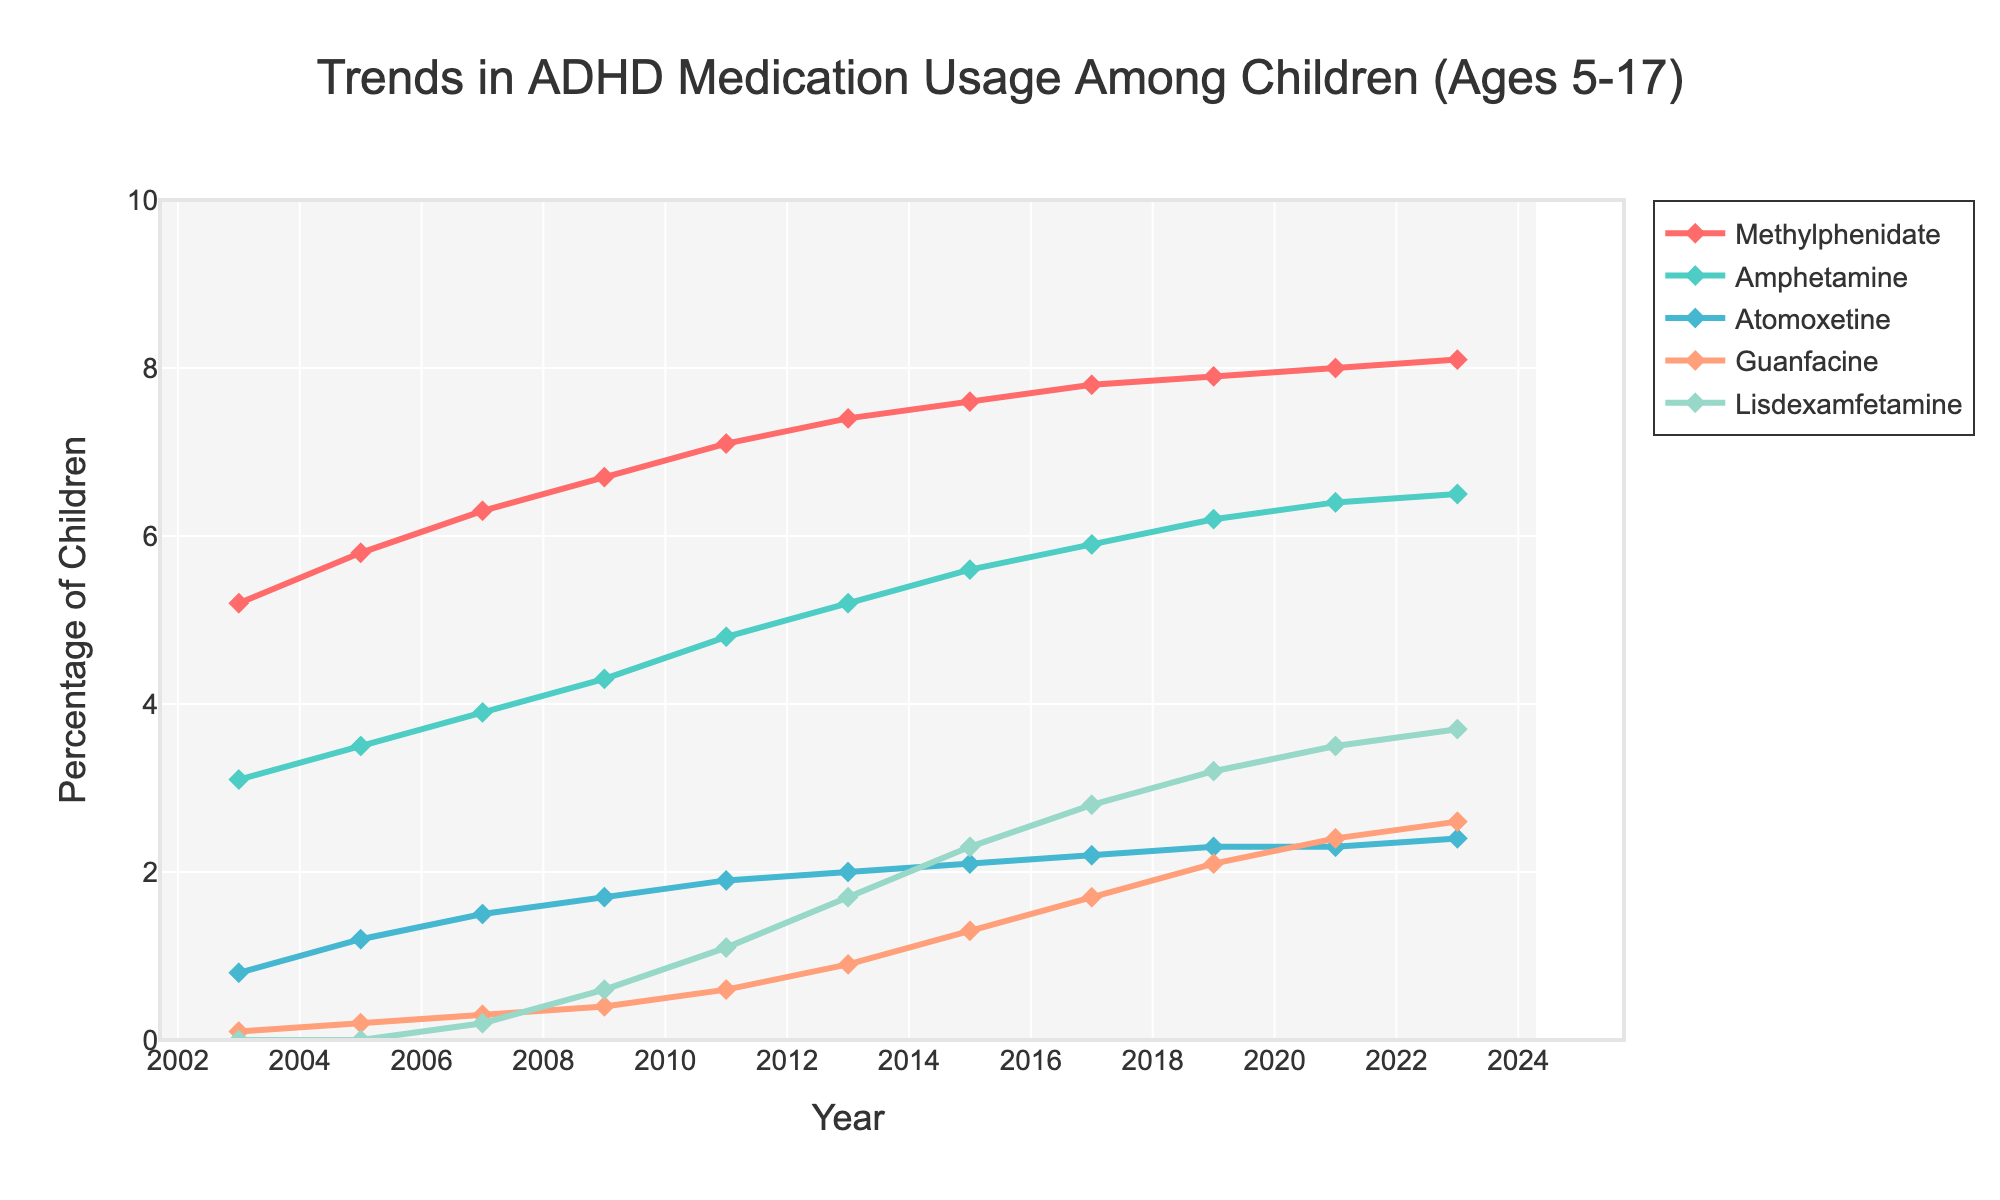What's the trend in Methylphenidate usage over the 20-year period? Methylphenidate usage increases from 5.2% in 2003 to 8.1% in 2023. Check each data point for Methylphenidate in the figure to notice the upward trend over time.
Answer: Increasing Which medication shows the most significant increase in usage over the 20 years? Calculate the increase in percentage for each medication: Methylphenidate (8.1-5.2=2.9), Amphetamine (6.5-3.1=3.4), Atomoxetine (2.4-0.8=1.6), Guanfacine (2.6-0.1=2.5), Lisdexamfetamine (3.7-0=3.7). The largest increase is for Lisdexamfetamine.
Answer: Lisdexamfetamine How does the 2023 usage of Guanfacine compare to Atomoxetine? In 2023, Guanfacine usage is 2.6% and Atomoxetine is 2.4%. Guanfacine usage is slightly higher.
Answer: Guanfacine is higher What is the difference in usage between Amphetamine and Atomoxetine in 2021? In 2021, Amphetamine is 6.4% and Atomoxetine is 2.3%. The difference is calculated as 6.4 - 2.3 = 4.1.
Answer: 4.1% Which medication had the least percentage of users in 2003 and how much was it? In 2003, the percentages are: Methylphenidate (5.2%), Amphetamine (3.1%), Atomoxetine (0.8%), Guanfacine (0.1%), Lisdexamfetamine (0%). The least is Lisdexamfetamine with 0%.
Answer: Lisdexamfetamine with 0% What's the average usage of Methylphenidate across all years? Sum all Methylphenidate percentages over the years (5.2 + 5.8 + 6.3 + 6.7 + 7.1 + 7.4 + 7.6 + 7.8 + 7.9 + 8.0 + 8.1) = 78.9, then divide by 11 (number of years) to get 78.9 / 11 ≈ 7.17.
Answer: 7.17% Which two medications had the closest usage rates in 2011? In 2011, the percentages are: Methylphenidate (7.1%), Amphetamine (4.8%), Atomoxetine (1.9%), Guanfacine (0.6%), Lisdexamfetamine (1.1%). The closest rates are between Atomoxetine and Lisdexamfetamine (1.9% and 1.1% respectively).
Answer: Atomoxetine and Lisdexamfetamine What is the trend for Lisdexamfetamine from its introduction to 2023? Lisdexamfetamine starts from 0% in 2003, increases in 2007 with 0.2%, and continues upward to reach 3.7% in 2023. Check each data point for Lisdexamfetamine to observe the upward trend.
Answer: Increasing 